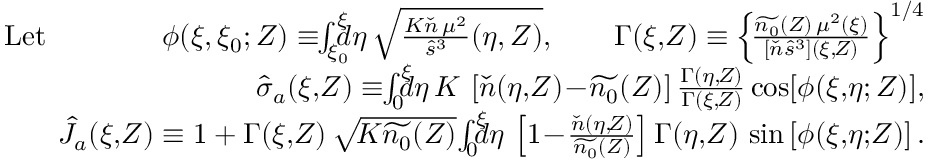<formula> <loc_0><loc_0><loc_500><loc_500>\begin{array} { r } { L e t \quad \phi ( \xi , \xi _ { 0 } ; Z ) \equiv \, \int _ { \xi _ { 0 } } ^ { \xi } \, d \eta \, \sqrt { \frac { K \check { n } \, \mu ^ { 2 } } { \hat { s } ^ { 3 } } ( \eta , Z ) } , \quad \Gamma ( \xi , \, Z ) \equiv \left \{ \, \frac { \widetilde { n _ { 0 } } ( Z ) \, \mu ^ { 2 } ( \xi ) } { [ \check { n } \hat { s } ^ { 3 } ] ( \xi , \, Z ) } \right \} ^ { 1 / 4 } } \\ { \hat { \sigma } _ { a } ( \xi , \, Z ) \equiv \, \int _ { 0 } ^ { \xi } \, d \eta \, K \, \left [ \check { n } ( \eta , \, Z ) \, - \, \widetilde { n _ { 0 } } ( Z ) \right ] \frac { \Gamma ( \eta , \, Z ) } { \Gamma ( \xi , \, Z ) } \cos [ \phi ( \xi , \, \eta ; Z ) ] , } \\ { \hat { J } _ { a } ( \xi , \, Z ) \equiv 1 + \Gamma ( \xi , \, Z ) \, \sqrt { \, K \widetilde { n _ { 0 } } ( Z ) } \, \int _ { 0 } ^ { \xi } \, d \eta \, \left [ 1 \, - \, \frac { \check { n } ( \eta , \, Z ) } { \widetilde { n _ { 0 } } ( Z ) } \right ] \Gamma ( \eta , \, Z ) \, \sin \left [ \phi ( \xi , \, \eta ; \, Z ) \right ] . } \end{array}</formula> 